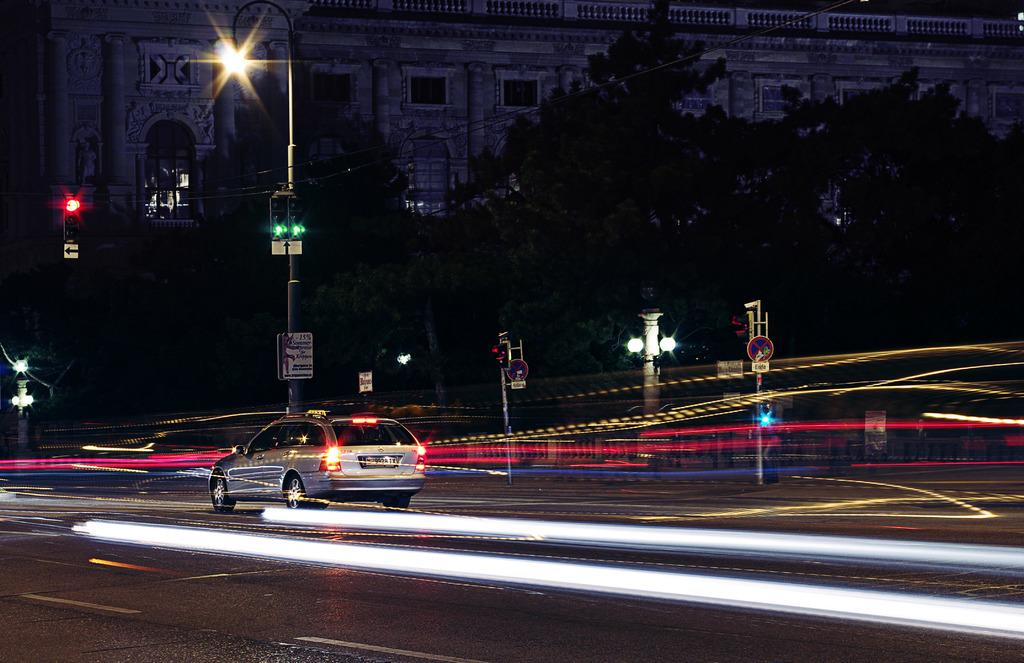What is the main subject of the image? The main subject of the image is a car. What is the car doing in the image? The car is moving on a road in the image. What can be seen in the background of the image? There are poles, trees, and buildings in the background of the image. What is the price of the coil that the car is carrying in the image? There is no coil present in the image, and the car is not carrying any visible objects. 